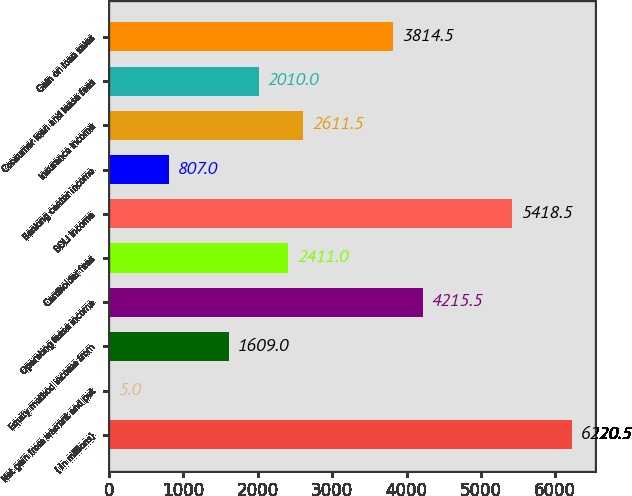Convert chart to OTSL. <chart><loc_0><loc_0><loc_500><loc_500><bar_chart><fcel>( in millions)<fcel>Net gain from warrant and put<fcel>Equity method income from<fcel>Operating lease income<fcel>Cardholder fees<fcel>BOLI income<fcel>Banking center income<fcel>Insurance income<fcel>Consumer loan and lease fees<fcel>Gain on loan sales<nl><fcel>6220.5<fcel>5<fcel>1609<fcel>4215.5<fcel>2411<fcel>5418.5<fcel>807<fcel>2611.5<fcel>2010<fcel>3814.5<nl></chart> 